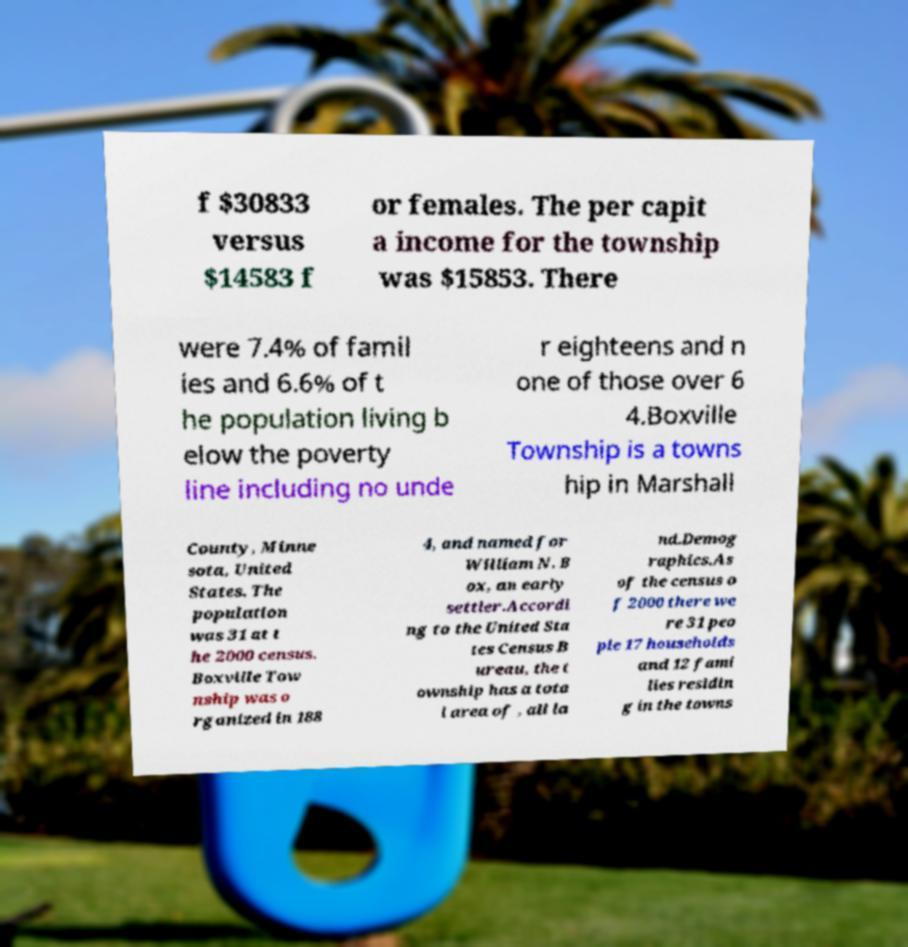Could you assist in decoding the text presented in this image and type it out clearly? f $30833 versus $14583 f or females. The per capit a income for the township was $15853. There were 7.4% of famil ies and 6.6% of t he population living b elow the poverty line including no unde r eighteens and n one of those over 6 4.Boxville Township is a towns hip in Marshall County, Minne sota, United States. The population was 31 at t he 2000 census. Boxville Tow nship was o rganized in 188 4, and named for William N. B ox, an early settler.Accordi ng to the United Sta tes Census B ureau, the t ownship has a tota l area of , all la nd.Demog raphics.As of the census o f 2000 there we re 31 peo ple 17 households and 12 fami lies residin g in the towns 